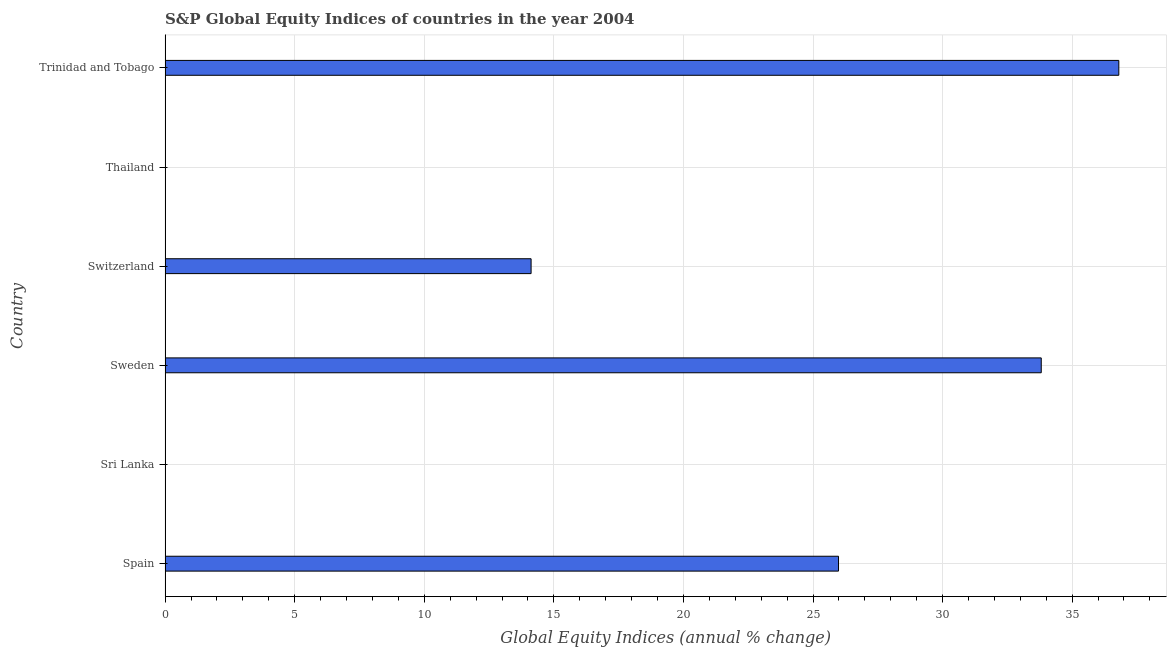Does the graph contain grids?
Ensure brevity in your answer.  Yes. What is the title of the graph?
Keep it short and to the point. S&P Global Equity Indices of countries in the year 2004. What is the label or title of the X-axis?
Give a very brief answer. Global Equity Indices (annual % change). What is the s&p global equity indices in Switzerland?
Ensure brevity in your answer.  14.12. Across all countries, what is the maximum s&p global equity indices?
Your answer should be very brief. 36.8. Across all countries, what is the minimum s&p global equity indices?
Offer a terse response. 0. In which country was the s&p global equity indices maximum?
Your response must be concise. Trinidad and Tobago. What is the sum of the s&p global equity indices?
Give a very brief answer. 110.71. What is the difference between the s&p global equity indices in Spain and Switzerland?
Your answer should be very brief. 11.86. What is the average s&p global equity indices per country?
Your answer should be very brief. 18.45. What is the median s&p global equity indices?
Offer a very short reply. 20.05. What is the ratio of the s&p global equity indices in Switzerland to that in Trinidad and Tobago?
Your response must be concise. 0.38. Is the difference between the s&p global equity indices in Spain and Trinidad and Tobago greater than the difference between any two countries?
Provide a short and direct response. No. What is the difference between the highest and the second highest s&p global equity indices?
Make the answer very short. 2.99. What is the difference between the highest and the lowest s&p global equity indices?
Ensure brevity in your answer.  36.8. In how many countries, is the s&p global equity indices greater than the average s&p global equity indices taken over all countries?
Provide a short and direct response. 3. How many bars are there?
Your answer should be compact. 4. What is the Global Equity Indices (annual % change) in Spain?
Your answer should be very brief. 25.98. What is the Global Equity Indices (annual % change) in Sweden?
Your answer should be compact. 33.81. What is the Global Equity Indices (annual % change) of Switzerland?
Offer a very short reply. 14.12. What is the Global Equity Indices (annual % change) in Trinidad and Tobago?
Keep it short and to the point. 36.8. What is the difference between the Global Equity Indices (annual % change) in Spain and Sweden?
Ensure brevity in your answer.  -7.82. What is the difference between the Global Equity Indices (annual % change) in Spain and Switzerland?
Keep it short and to the point. 11.86. What is the difference between the Global Equity Indices (annual % change) in Spain and Trinidad and Tobago?
Keep it short and to the point. -10.82. What is the difference between the Global Equity Indices (annual % change) in Sweden and Switzerland?
Your response must be concise. 19.68. What is the difference between the Global Equity Indices (annual % change) in Sweden and Trinidad and Tobago?
Your answer should be compact. -2.99. What is the difference between the Global Equity Indices (annual % change) in Switzerland and Trinidad and Tobago?
Provide a succinct answer. -22.68. What is the ratio of the Global Equity Indices (annual % change) in Spain to that in Sweden?
Offer a very short reply. 0.77. What is the ratio of the Global Equity Indices (annual % change) in Spain to that in Switzerland?
Provide a succinct answer. 1.84. What is the ratio of the Global Equity Indices (annual % change) in Spain to that in Trinidad and Tobago?
Offer a terse response. 0.71. What is the ratio of the Global Equity Indices (annual % change) in Sweden to that in Switzerland?
Make the answer very short. 2.39. What is the ratio of the Global Equity Indices (annual % change) in Sweden to that in Trinidad and Tobago?
Offer a terse response. 0.92. What is the ratio of the Global Equity Indices (annual % change) in Switzerland to that in Trinidad and Tobago?
Keep it short and to the point. 0.38. 